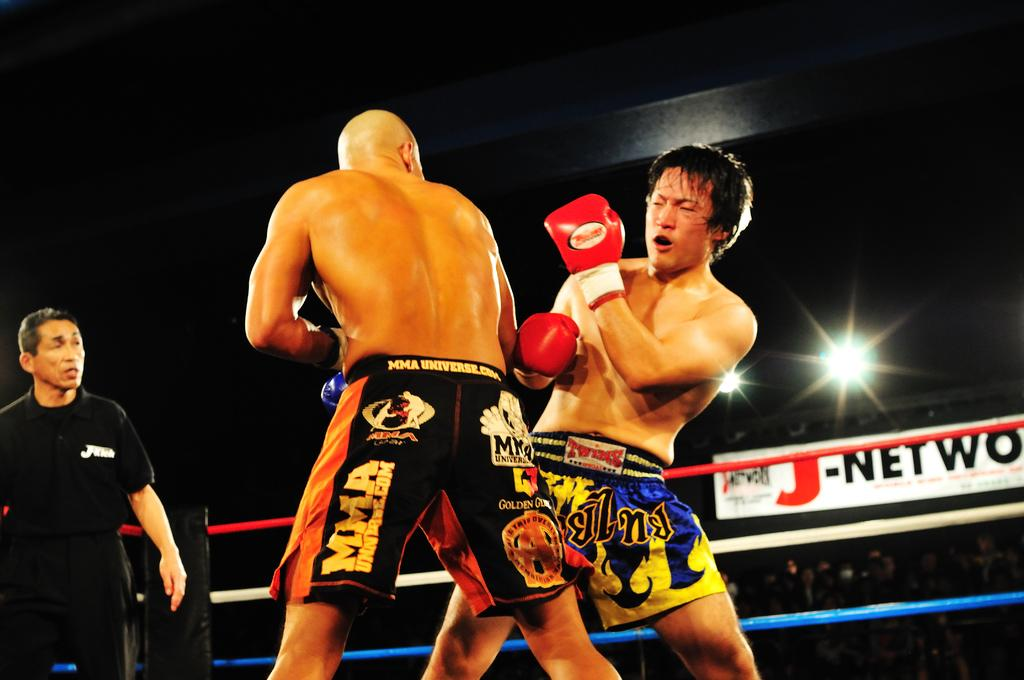<image>
Present a compact description of the photo's key features. Two men boxing with one man's whose shorts say MMA. 